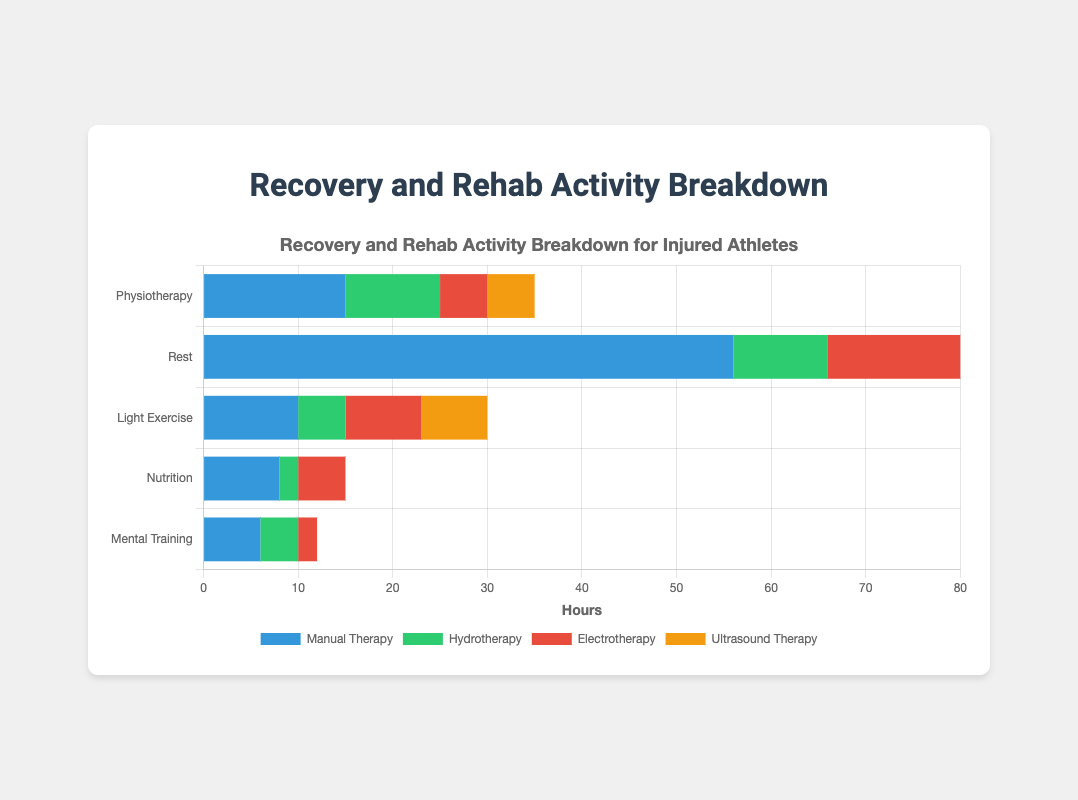Which activity has the highest total hours spent? By visually inspecting the stacked bar lengths, "Rest" appears to have the longest bar. Summing the hours of sessions under "Rest" provides Sleep (56) + Nap (10) + Relaxation (14) = 80, which is the highest among all activities.
Answer: Rest How many more hours are spent on Sleep than on Manual Therapy? Sleep has 56 hours, and Manual Therapy has 15 hours. The difference is 56 - 15 = 41 hours.
Answer: 41 hours What is the total number of hours spent on Mental Training? Adding the hours of all sessions under "Mental Training" provides Meditation (6) + Visualization (4) + Sports Psychology Consult (2) = 12 hours.
Answer: 12 hours Which session within Light Exercise has the fewest hours, and how many hours is that? From visual inspection, "Stretching" has the shortest bar within "Light Exercise" with 5 hours.
Answer: Stretching, 5 hours How do the total hours spent on Physiotherapy compare to the total hours spent on Mental Training? Summing the hours for Physiotherapy: Manual Therapy (15) + Hydrotherapy (10) + Electrotherapy (5) + Ultrasound Therapy (5) = 35 hours. For Mental Training, it's 12 hours. Comparing both, 35 is greater than 12.
Answer: Physiotherapy greater than Mental Training What are the combined hours for all activities involving therapy (Physiotherapy and Mental Training)? Summing all therapy-related hours: Physiotherapy (15+10+5+5 = 35) and Mental Training (6+4+2 = 12), giving 35 + 12 = 47 hours.
Answer: 47 hours Which session has the highest number of hours within the Nutrition category, and how many hours? By visual inspection, "Meal Prep" has the longest bar in Nutrition with 8 hours.
Answer: Meal Prep, 8 hours 